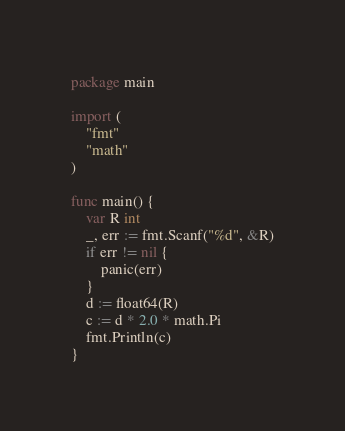<code> <loc_0><loc_0><loc_500><loc_500><_Go_>package main

import (
	"fmt"
	"math"
)

func main() {
	var R int
	_, err := fmt.Scanf("%d", &R)
	if err != nil {
		panic(err)
	}
	d := float64(R)
	c := d * 2.0 * math.Pi
	fmt.Println(c)
}</code> 